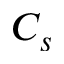Convert formula to latex. <formula><loc_0><loc_0><loc_500><loc_500>C _ { s }</formula> 